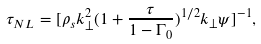<formula> <loc_0><loc_0><loc_500><loc_500>\tau _ { N L } = [ \rho _ { s } k _ { \perp } ^ { 2 } ( 1 + \frac { \tau } { 1 - \Gamma _ { 0 } } ) ^ { 1 / 2 } k _ { \perp } \psi ] ^ { - 1 } ,</formula> 